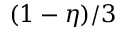<formula> <loc_0><loc_0><loc_500><loc_500>( 1 - \eta ) / 3</formula> 